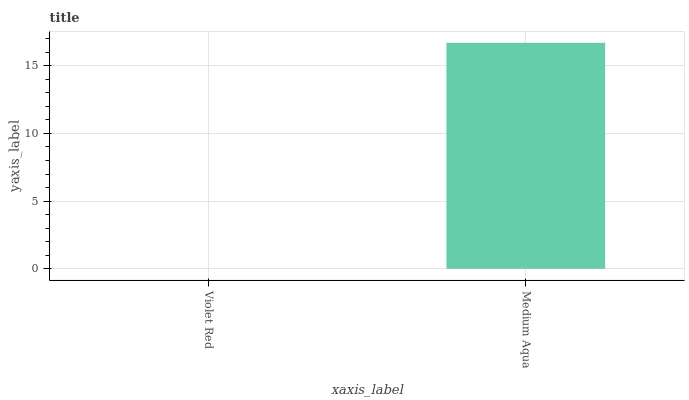Is Violet Red the minimum?
Answer yes or no. Yes. Is Medium Aqua the maximum?
Answer yes or no. Yes. Is Medium Aqua the minimum?
Answer yes or no. No. Is Medium Aqua greater than Violet Red?
Answer yes or no. Yes. Is Violet Red less than Medium Aqua?
Answer yes or no. Yes. Is Violet Red greater than Medium Aqua?
Answer yes or no. No. Is Medium Aqua less than Violet Red?
Answer yes or no. No. Is Medium Aqua the high median?
Answer yes or no. Yes. Is Violet Red the low median?
Answer yes or no. Yes. Is Violet Red the high median?
Answer yes or no. No. Is Medium Aqua the low median?
Answer yes or no. No. 